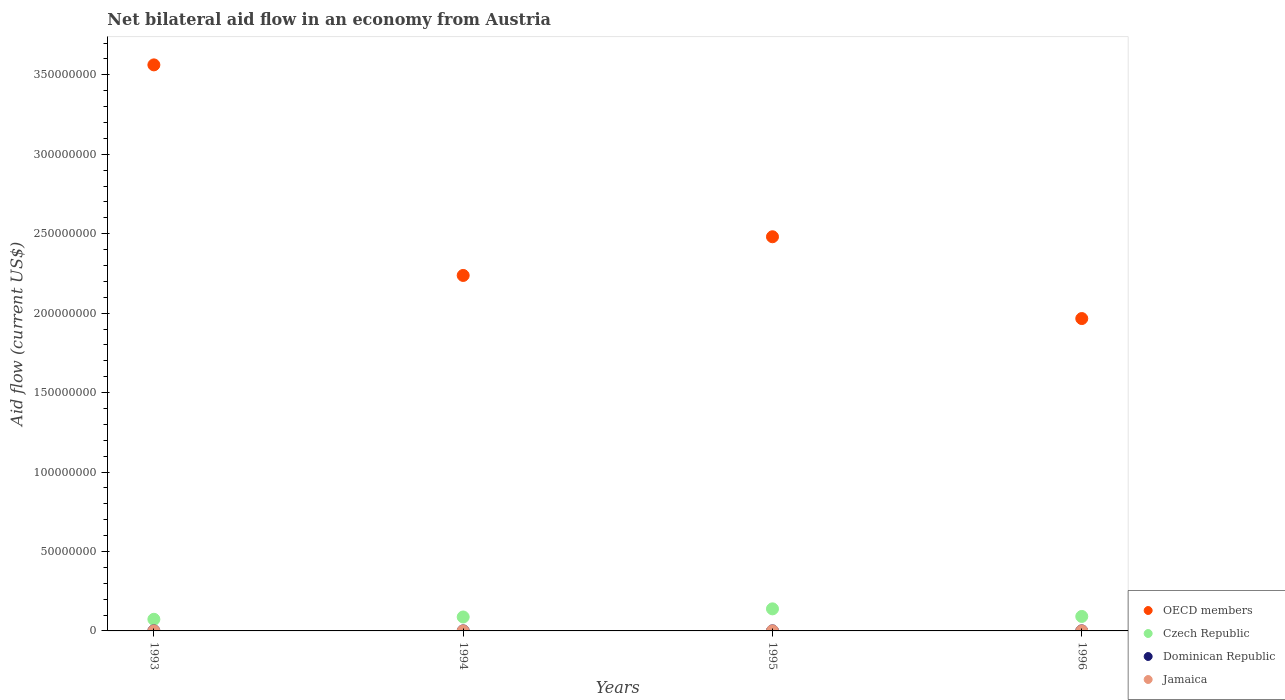How many different coloured dotlines are there?
Ensure brevity in your answer.  4. What is the net bilateral aid flow in Jamaica in 1993?
Your answer should be compact. 2.00e+04. Across all years, what is the maximum net bilateral aid flow in Jamaica?
Provide a short and direct response. 2.00e+04. Across all years, what is the minimum net bilateral aid flow in OECD members?
Offer a very short reply. 1.97e+08. In which year was the net bilateral aid flow in OECD members maximum?
Ensure brevity in your answer.  1993. What is the difference between the net bilateral aid flow in OECD members in 1994 and that in 1995?
Ensure brevity in your answer.  -2.44e+07. What is the average net bilateral aid flow in Jamaica per year?
Your response must be concise. 1.75e+04. In the year 1994, what is the difference between the net bilateral aid flow in Jamaica and net bilateral aid flow in Czech Republic?
Provide a succinct answer. -8.76e+06. In how many years, is the net bilateral aid flow in Dominican Republic greater than 330000000 US$?
Provide a short and direct response. 0. What is the ratio of the net bilateral aid flow in Czech Republic in 1994 to that in 1996?
Make the answer very short. 0.96. Is the difference between the net bilateral aid flow in Jamaica in 1993 and 1996 greater than the difference between the net bilateral aid flow in Czech Republic in 1993 and 1996?
Keep it short and to the point. Yes. What is the difference between the highest and the second highest net bilateral aid flow in Czech Republic?
Make the answer very short. 4.78e+06. Is the sum of the net bilateral aid flow in Czech Republic in 1993 and 1995 greater than the maximum net bilateral aid flow in Dominican Republic across all years?
Keep it short and to the point. Yes. Does the net bilateral aid flow in Dominican Republic monotonically increase over the years?
Ensure brevity in your answer.  No. How many years are there in the graph?
Offer a terse response. 4. Are the values on the major ticks of Y-axis written in scientific E-notation?
Your answer should be very brief. No. Does the graph contain any zero values?
Make the answer very short. No. Does the graph contain grids?
Your answer should be very brief. No. How are the legend labels stacked?
Your answer should be very brief. Vertical. What is the title of the graph?
Your answer should be very brief. Net bilateral aid flow in an economy from Austria. Does "Aruba" appear as one of the legend labels in the graph?
Give a very brief answer. No. What is the label or title of the Y-axis?
Offer a terse response. Aid flow (current US$). What is the Aid flow (current US$) of OECD members in 1993?
Provide a short and direct response. 3.56e+08. What is the Aid flow (current US$) of Czech Republic in 1993?
Keep it short and to the point. 7.32e+06. What is the Aid flow (current US$) in OECD members in 1994?
Your answer should be very brief. 2.24e+08. What is the Aid flow (current US$) in Czech Republic in 1994?
Offer a very short reply. 8.77e+06. What is the Aid flow (current US$) in OECD members in 1995?
Offer a very short reply. 2.48e+08. What is the Aid flow (current US$) in Czech Republic in 1995?
Ensure brevity in your answer.  1.39e+07. What is the Aid flow (current US$) in Jamaica in 1995?
Ensure brevity in your answer.  2.00e+04. What is the Aid flow (current US$) of OECD members in 1996?
Ensure brevity in your answer.  1.97e+08. What is the Aid flow (current US$) of Czech Republic in 1996?
Provide a short and direct response. 9.11e+06. What is the Aid flow (current US$) of Dominican Republic in 1996?
Your answer should be very brief. 3.00e+04. Across all years, what is the maximum Aid flow (current US$) of OECD members?
Your answer should be very brief. 3.56e+08. Across all years, what is the maximum Aid flow (current US$) in Czech Republic?
Keep it short and to the point. 1.39e+07. Across all years, what is the minimum Aid flow (current US$) in OECD members?
Make the answer very short. 1.97e+08. Across all years, what is the minimum Aid flow (current US$) in Czech Republic?
Offer a very short reply. 7.32e+06. Across all years, what is the minimum Aid flow (current US$) of Dominican Republic?
Your answer should be compact. 2.00e+04. Across all years, what is the minimum Aid flow (current US$) of Jamaica?
Offer a very short reply. 10000. What is the total Aid flow (current US$) in OECD members in the graph?
Provide a short and direct response. 1.02e+09. What is the total Aid flow (current US$) of Czech Republic in the graph?
Offer a very short reply. 3.91e+07. What is the total Aid flow (current US$) in Dominican Republic in the graph?
Your response must be concise. 1.30e+05. What is the total Aid flow (current US$) of Jamaica in the graph?
Provide a succinct answer. 7.00e+04. What is the difference between the Aid flow (current US$) of OECD members in 1993 and that in 1994?
Give a very brief answer. 1.33e+08. What is the difference between the Aid flow (current US$) of Czech Republic in 1993 and that in 1994?
Give a very brief answer. -1.45e+06. What is the difference between the Aid flow (current US$) of Dominican Republic in 1993 and that in 1994?
Your response must be concise. 2.00e+04. What is the difference between the Aid flow (current US$) in Jamaica in 1993 and that in 1994?
Ensure brevity in your answer.  10000. What is the difference between the Aid flow (current US$) in OECD members in 1993 and that in 1995?
Make the answer very short. 1.08e+08. What is the difference between the Aid flow (current US$) in Czech Republic in 1993 and that in 1995?
Offer a terse response. -6.57e+06. What is the difference between the Aid flow (current US$) of Jamaica in 1993 and that in 1995?
Your response must be concise. 0. What is the difference between the Aid flow (current US$) of OECD members in 1993 and that in 1996?
Offer a very short reply. 1.60e+08. What is the difference between the Aid flow (current US$) in Czech Republic in 1993 and that in 1996?
Ensure brevity in your answer.  -1.79e+06. What is the difference between the Aid flow (current US$) in Jamaica in 1993 and that in 1996?
Give a very brief answer. 0. What is the difference between the Aid flow (current US$) of OECD members in 1994 and that in 1995?
Offer a terse response. -2.44e+07. What is the difference between the Aid flow (current US$) in Czech Republic in 1994 and that in 1995?
Your answer should be compact. -5.12e+06. What is the difference between the Aid flow (current US$) of Dominican Republic in 1994 and that in 1995?
Ensure brevity in your answer.  -2.00e+04. What is the difference between the Aid flow (current US$) of Jamaica in 1994 and that in 1995?
Keep it short and to the point. -10000. What is the difference between the Aid flow (current US$) of OECD members in 1994 and that in 1996?
Ensure brevity in your answer.  2.71e+07. What is the difference between the Aid flow (current US$) of Czech Republic in 1994 and that in 1996?
Your answer should be very brief. -3.40e+05. What is the difference between the Aid flow (current US$) in Dominican Republic in 1994 and that in 1996?
Offer a terse response. -10000. What is the difference between the Aid flow (current US$) of Jamaica in 1994 and that in 1996?
Your answer should be compact. -10000. What is the difference between the Aid flow (current US$) in OECD members in 1995 and that in 1996?
Your response must be concise. 5.15e+07. What is the difference between the Aid flow (current US$) of Czech Republic in 1995 and that in 1996?
Your answer should be very brief. 4.78e+06. What is the difference between the Aid flow (current US$) in OECD members in 1993 and the Aid flow (current US$) in Czech Republic in 1994?
Give a very brief answer. 3.47e+08. What is the difference between the Aid flow (current US$) in OECD members in 1993 and the Aid flow (current US$) in Dominican Republic in 1994?
Provide a succinct answer. 3.56e+08. What is the difference between the Aid flow (current US$) of OECD members in 1993 and the Aid flow (current US$) of Jamaica in 1994?
Provide a succinct answer. 3.56e+08. What is the difference between the Aid flow (current US$) in Czech Republic in 1993 and the Aid flow (current US$) in Dominican Republic in 1994?
Provide a short and direct response. 7.30e+06. What is the difference between the Aid flow (current US$) of Czech Republic in 1993 and the Aid flow (current US$) of Jamaica in 1994?
Make the answer very short. 7.31e+06. What is the difference between the Aid flow (current US$) of Dominican Republic in 1993 and the Aid flow (current US$) of Jamaica in 1994?
Your answer should be compact. 3.00e+04. What is the difference between the Aid flow (current US$) of OECD members in 1993 and the Aid flow (current US$) of Czech Republic in 1995?
Provide a succinct answer. 3.42e+08. What is the difference between the Aid flow (current US$) of OECD members in 1993 and the Aid flow (current US$) of Dominican Republic in 1995?
Give a very brief answer. 3.56e+08. What is the difference between the Aid flow (current US$) of OECD members in 1993 and the Aid flow (current US$) of Jamaica in 1995?
Provide a succinct answer. 3.56e+08. What is the difference between the Aid flow (current US$) in Czech Republic in 1993 and the Aid flow (current US$) in Dominican Republic in 1995?
Your response must be concise. 7.28e+06. What is the difference between the Aid flow (current US$) in Czech Republic in 1993 and the Aid flow (current US$) in Jamaica in 1995?
Offer a terse response. 7.30e+06. What is the difference between the Aid flow (current US$) in Dominican Republic in 1993 and the Aid flow (current US$) in Jamaica in 1995?
Your answer should be compact. 2.00e+04. What is the difference between the Aid flow (current US$) in OECD members in 1993 and the Aid flow (current US$) in Czech Republic in 1996?
Offer a very short reply. 3.47e+08. What is the difference between the Aid flow (current US$) of OECD members in 1993 and the Aid flow (current US$) of Dominican Republic in 1996?
Your answer should be very brief. 3.56e+08. What is the difference between the Aid flow (current US$) of OECD members in 1993 and the Aid flow (current US$) of Jamaica in 1996?
Offer a very short reply. 3.56e+08. What is the difference between the Aid flow (current US$) of Czech Republic in 1993 and the Aid flow (current US$) of Dominican Republic in 1996?
Provide a short and direct response. 7.29e+06. What is the difference between the Aid flow (current US$) of Czech Republic in 1993 and the Aid flow (current US$) of Jamaica in 1996?
Offer a terse response. 7.30e+06. What is the difference between the Aid flow (current US$) in Dominican Republic in 1993 and the Aid flow (current US$) in Jamaica in 1996?
Your answer should be compact. 2.00e+04. What is the difference between the Aid flow (current US$) in OECD members in 1994 and the Aid flow (current US$) in Czech Republic in 1995?
Provide a succinct answer. 2.10e+08. What is the difference between the Aid flow (current US$) of OECD members in 1994 and the Aid flow (current US$) of Dominican Republic in 1995?
Offer a terse response. 2.24e+08. What is the difference between the Aid flow (current US$) in OECD members in 1994 and the Aid flow (current US$) in Jamaica in 1995?
Your answer should be very brief. 2.24e+08. What is the difference between the Aid flow (current US$) of Czech Republic in 1994 and the Aid flow (current US$) of Dominican Republic in 1995?
Your response must be concise. 8.73e+06. What is the difference between the Aid flow (current US$) of Czech Republic in 1994 and the Aid flow (current US$) of Jamaica in 1995?
Offer a very short reply. 8.75e+06. What is the difference between the Aid flow (current US$) of OECD members in 1994 and the Aid flow (current US$) of Czech Republic in 1996?
Offer a terse response. 2.15e+08. What is the difference between the Aid flow (current US$) in OECD members in 1994 and the Aid flow (current US$) in Dominican Republic in 1996?
Offer a very short reply. 2.24e+08. What is the difference between the Aid flow (current US$) of OECD members in 1994 and the Aid flow (current US$) of Jamaica in 1996?
Your response must be concise. 2.24e+08. What is the difference between the Aid flow (current US$) of Czech Republic in 1994 and the Aid flow (current US$) of Dominican Republic in 1996?
Your answer should be compact. 8.74e+06. What is the difference between the Aid flow (current US$) in Czech Republic in 1994 and the Aid flow (current US$) in Jamaica in 1996?
Offer a terse response. 8.75e+06. What is the difference between the Aid flow (current US$) in Dominican Republic in 1994 and the Aid flow (current US$) in Jamaica in 1996?
Keep it short and to the point. 0. What is the difference between the Aid flow (current US$) in OECD members in 1995 and the Aid flow (current US$) in Czech Republic in 1996?
Offer a terse response. 2.39e+08. What is the difference between the Aid flow (current US$) of OECD members in 1995 and the Aid flow (current US$) of Dominican Republic in 1996?
Your response must be concise. 2.48e+08. What is the difference between the Aid flow (current US$) of OECD members in 1995 and the Aid flow (current US$) of Jamaica in 1996?
Provide a short and direct response. 2.48e+08. What is the difference between the Aid flow (current US$) of Czech Republic in 1995 and the Aid flow (current US$) of Dominican Republic in 1996?
Ensure brevity in your answer.  1.39e+07. What is the difference between the Aid flow (current US$) in Czech Republic in 1995 and the Aid flow (current US$) in Jamaica in 1996?
Keep it short and to the point. 1.39e+07. What is the average Aid flow (current US$) in OECD members per year?
Make the answer very short. 2.56e+08. What is the average Aid flow (current US$) of Czech Republic per year?
Provide a short and direct response. 9.77e+06. What is the average Aid flow (current US$) of Dominican Republic per year?
Give a very brief answer. 3.25e+04. What is the average Aid flow (current US$) in Jamaica per year?
Provide a succinct answer. 1.75e+04. In the year 1993, what is the difference between the Aid flow (current US$) of OECD members and Aid flow (current US$) of Czech Republic?
Ensure brevity in your answer.  3.49e+08. In the year 1993, what is the difference between the Aid flow (current US$) in OECD members and Aid flow (current US$) in Dominican Republic?
Offer a very short reply. 3.56e+08. In the year 1993, what is the difference between the Aid flow (current US$) of OECD members and Aid flow (current US$) of Jamaica?
Provide a succinct answer. 3.56e+08. In the year 1993, what is the difference between the Aid flow (current US$) of Czech Republic and Aid flow (current US$) of Dominican Republic?
Make the answer very short. 7.28e+06. In the year 1993, what is the difference between the Aid flow (current US$) of Czech Republic and Aid flow (current US$) of Jamaica?
Your answer should be compact. 7.30e+06. In the year 1994, what is the difference between the Aid flow (current US$) of OECD members and Aid flow (current US$) of Czech Republic?
Your response must be concise. 2.15e+08. In the year 1994, what is the difference between the Aid flow (current US$) in OECD members and Aid flow (current US$) in Dominican Republic?
Offer a terse response. 2.24e+08. In the year 1994, what is the difference between the Aid flow (current US$) in OECD members and Aid flow (current US$) in Jamaica?
Offer a very short reply. 2.24e+08. In the year 1994, what is the difference between the Aid flow (current US$) of Czech Republic and Aid flow (current US$) of Dominican Republic?
Your answer should be very brief. 8.75e+06. In the year 1994, what is the difference between the Aid flow (current US$) of Czech Republic and Aid flow (current US$) of Jamaica?
Ensure brevity in your answer.  8.76e+06. In the year 1995, what is the difference between the Aid flow (current US$) in OECD members and Aid flow (current US$) in Czech Republic?
Keep it short and to the point. 2.34e+08. In the year 1995, what is the difference between the Aid flow (current US$) of OECD members and Aid flow (current US$) of Dominican Republic?
Offer a very short reply. 2.48e+08. In the year 1995, what is the difference between the Aid flow (current US$) of OECD members and Aid flow (current US$) of Jamaica?
Make the answer very short. 2.48e+08. In the year 1995, what is the difference between the Aid flow (current US$) in Czech Republic and Aid flow (current US$) in Dominican Republic?
Provide a short and direct response. 1.38e+07. In the year 1995, what is the difference between the Aid flow (current US$) in Czech Republic and Aid flow (current US$) in Jamaica?
Give a very brief answer. 1.39e+07. In the year 1996, what is the difference between the Aid flow (current US$) in OECD members and Aid flow (current US$) in Czech Republic?
Provide a short and direct response. 1.87e+08. In the year 1996, what is the difference between the Aid flow (current US$) of OECD members and Aid flow (current US$) of Dominican Republic?
Ensure brevity in your answer.  1.97e+08. In the year 1996, what is the difference between the Aid flow (current US$) of OECD members and Aid flow (current US$) of Jamaica?
Ensure brevity in your answer.  1.97e+08. In the year 1996, what is the difference between the Aid flow (current US$) of Czech Republic and Aid flow (current US$) of Dominican Republic?
Your answer should be compact. 9.08e+06. In the year 1996, what is the difference between the Aid flow (current US$) in Czech Republic and Aid flow (current US$) in Jamaica?
Make the answer very short. 9.09e+06. In the year 1996, what is the difference between the Aid flow (current US$) of Dominican Republic and Aid flow (current US$) of Jamaica?
Provide a succinct answer. 10000. What is the ratio of the Aid flow (current US$) in OECD members in 1993 to that in 1994?
Your answer should be very brief. 1.59. What is the ratio of the Aid flow (current US$) in Czech Republic in 1993 to that in 1994?
Offer a very short reply. 0.83. What is the ratio of the Aid flow (current US$) of OECD members in 1993 to that in 1995?
Give a very brief answer. 1.44. What is the ratio of the Aid flow (current US$) of Czech Republic in 1993 to that in 1995?
Make the answer very short. 0.53. What is the ratio of the Aid flow (current US$) in Dominican Republic in 1993 to that in 1995?
Make the answer very short. 1. What is the ratio of the Aid flow (current US$) of Jamaica in 1993 to that in 1995?
Your response must be concise. 1. What is the ratio of the Aid flow (current US$) in OECD members in 1993 to that in 1996?
Provide a short and direct response. 1.81. What is the ratio of the Aid flow (current US$) in Czech Republic in 1993 to that in 1996?
Provide a succinct answer. 0.8. What is the ratio of the Aid flow (current US$) in Jamaica in 1993 to that in 1996?
Your answer should be compact. 1. What is the ratio of the Aid flow (current US$) of OECD members in 1994 to that in 1995?
Offer a terse response. 0.9. What is the ratio of the Aid flow (current US$) of Czech Republic in 1994 to that in 1995?
Keep it short and to the point. 0.63. What is the ratio of the Aid flow (current US$) of OECD members in 1994 to that in 1996?
Your response must be concise. 1.14. What is the ratio of the Aid flow (current US$) in Czech Republic in 1994 to that in 1996?
Offer a very short reply. 0.96. What is the ratio of the Aid flow (current US$) of Dominican Republic in 1994 to that in 1996?
Make the answer very short. 0.67. What is the ratio of the Aid flow (current US$) in OECD members in 1995 to that in 1996?
Offer a terse response. 1.26. What is the ratio of the Aid flow (current US$) of Czech Republic in 1995 to that in 1996?
Make the answer very short. 1.52. What is the ratio of the Aid flow (current US$) of Dominican Republic in 1995 to that in 1996?
Give a very brief answer. 1.33. What is the ratio of the Aid flow (current US$) of Jamaica in 1995 to that in 1996?
Make the answer very short. 1. What is the difference between the highest and the second highest Aid flow (current US$) in OECD members?
Provide a succinct answer. 1.08e+08. What is the difference between the highest and the second highest Aid flow (current US$) of Czech Republic?
Provide a short and direct response. 4.78e+06. What is the difference between the highest and the second highest Aid flow (current US$) of Dominican Republic?
Keep it short and to the point. 0. What is the difference between the highest and the lowest Aid flow (current US$) in OECD members?
Your response must be concise. 1.60e+08. What is the difference between the highest and the lowest Aid flow (current US$) in Czech Republic?
Offer a very short reply. 6.57e+06. What is the difference between the highest and the lowest Aid flow (current US$) of Dominican Republic?
Provide a succinct answer. 2.00e+04. What is the difference between the highest and the lowest Aid flow (current US$) of Jamaica?
Provide a short and direct response. 10000. 